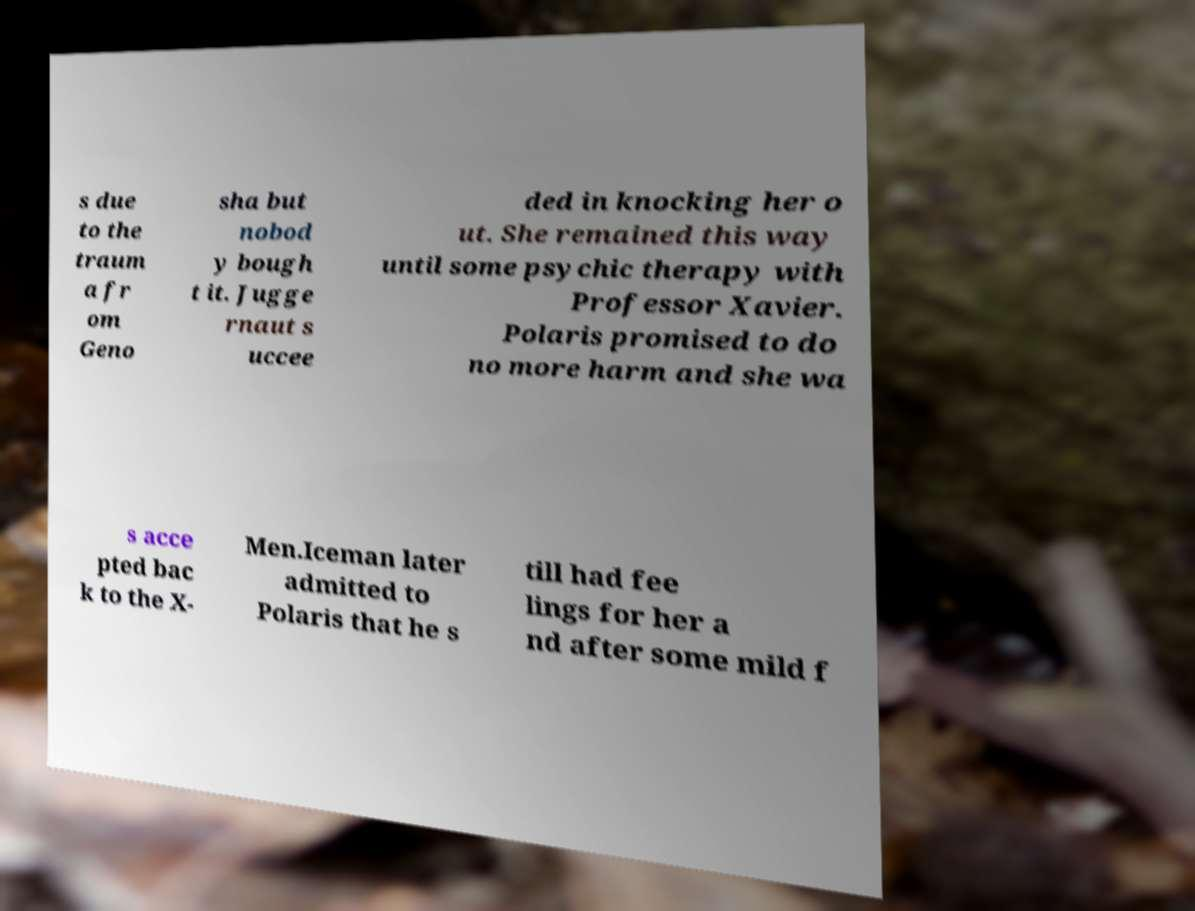Could you extract and type out the text from this image? s due to the traum a fr om Geno sha but nobod y bough t it. Jugge rnaut s uccee ded in knocking her o ut. She remained this way until some psychic therapy with Professor Xavier. Polaris promised to do no more harm and she wa s acce pted bac k to the X- Men.Iceman later admitted to Polaris that he s till had fee lings for her a nd after some mild f 